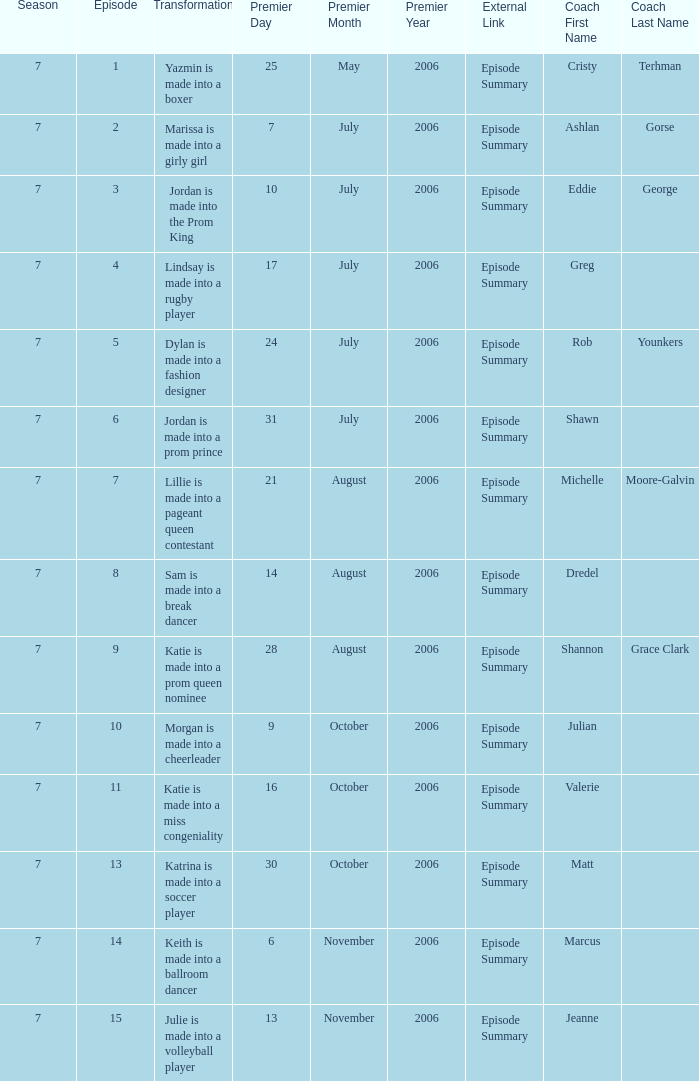What the summary of episode 15? Julie is made into a volleyball player. 